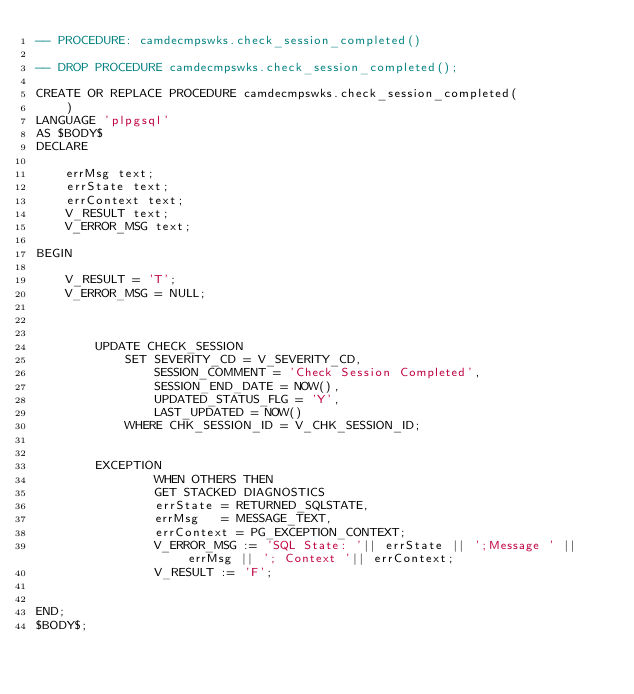<code> <loc_0><loc_0><loc_500><loc_500><_SQL_>-- PROCEDURE: camdecmpswks.check_session_completed()

-- DROP PROCEDURE camdecmpswks.check_session_completed();

CREATE OR REPLACE PROCEDURE camdecmpswks.check_session_completed(
	)
LANGUAGE 'plpgsql'
AS $BODY$
DECLARE

	errMsg text;
	errState text;
	errContext text;
	V_RESULT text;
	V_ERROR_MSG text;

BEGIN
	
	V_RESULT = 'T';
	V_ERROR_MSG = NULL;

	

		UPDATE CHECK_SESSION
			SET SEVERITY_CD = V_SEVERITY_CD,
				SESSION_COMMENT = 'Check Session Completed',
				SESSION_END_DATE = NOW(),
				UPDATED_STATUS_FLG = 'Y',
				LAST_UPDATED = NOW()
			WHERE CHK_SESSION_ID = V_CHK_SESSION_ID;
			

		EXCEPTION
				WHEN OTHERS THEN
				GET STACKED DIAGNOSTICS
				errState = RETURNED_SQLSTATE,
				errMsg   = MESSAGE_TEXT,
				errContext = PG_EXCEPTION_CONTEXT;
				V_ERROR_MSG := 'SQL State: '|| errState || ';Message ' || errMsg || '; Context '|| errContext;
				V_RESULT := 'F';
				
	
END;
$BODY$;
</code> 